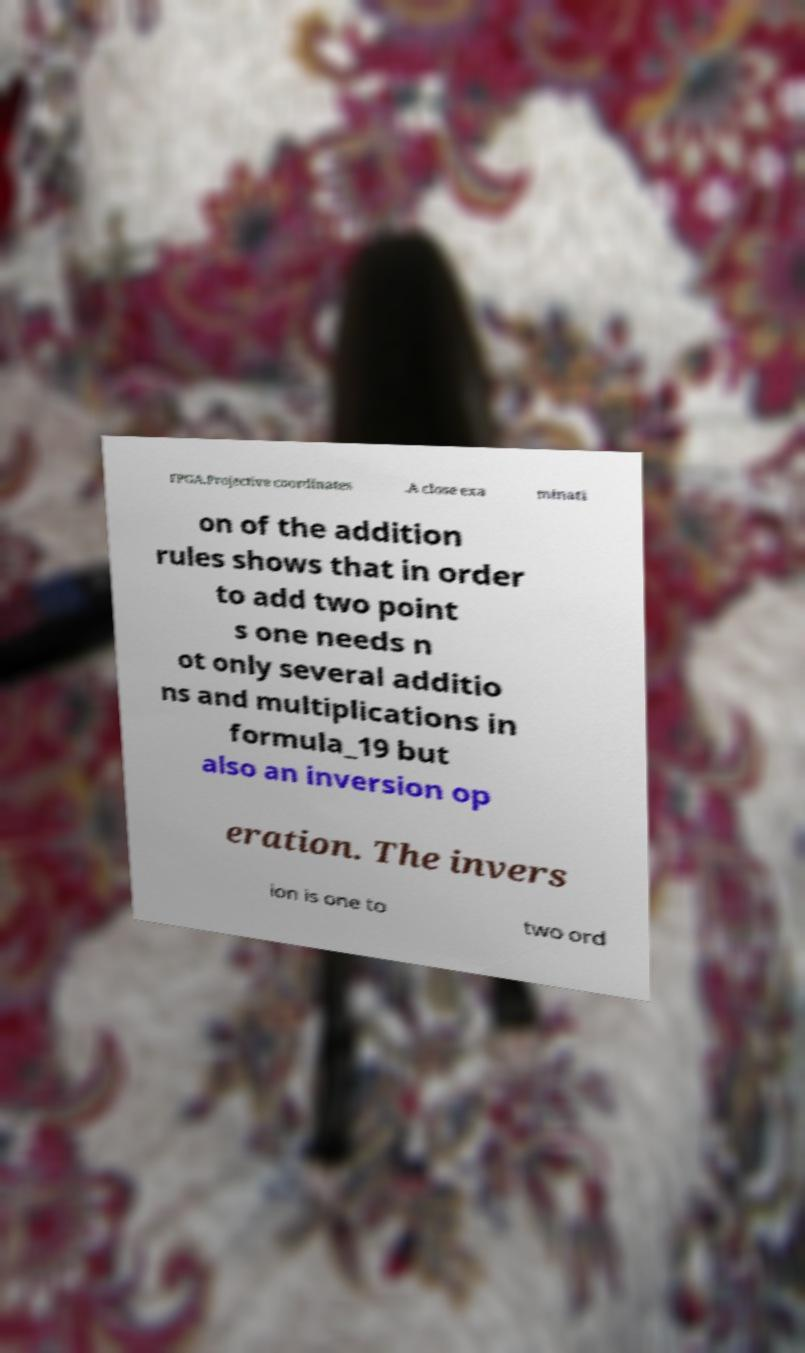There's text embedded in this image that I need extracted. Can you transcribe it verbatim? FPGA.Projective coordinates .A close exa minati on of the addition rules shows that in order to add two point s one needs n ot only several additio ns and multiplications in formula_19 but also an inversion op eration. The invers ion is one to two ord 